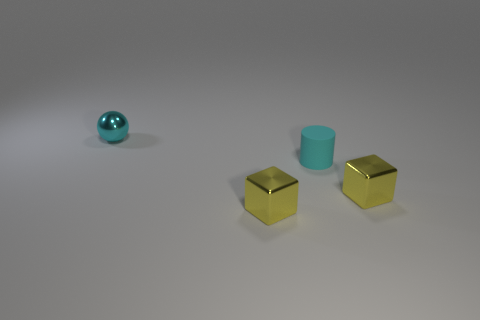Add 1 cyan balls. How many objects exist? 5 Subtract all cylinders. How many objects are left? 3 Add 2 small yellow metallic objects. How many small yellow metallic objects exist? 4 Subtract 0 blue cylinders. How many objects are left? 4 Subtract all yellow cylinders. Subtract all purple blocks. How many cylinders are left? 1 Subtract all yellow spheres. How many brown blocks are left? 0 Subtract all cyan spheres. Subtract all tiny gray matte things. How many objects are left? 3 Add 3 matte cylinders. How many matte cylinders are left? 4 